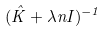<formula> <loc_0><loc_0><loc_500><loc_500>( \hat { K } + \lambda n I ) ^ { - 1 }</formula> 